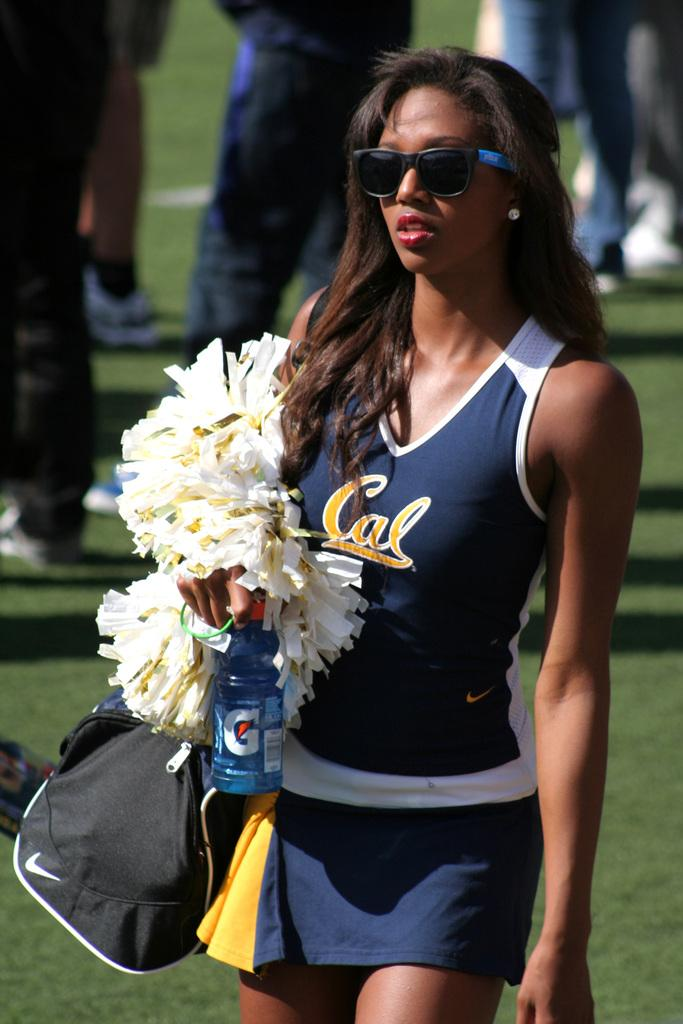Provide a one-sentence caption for the provided image. A cheerleader in a Cal tank carries her bag along with a drink and pom poms. 